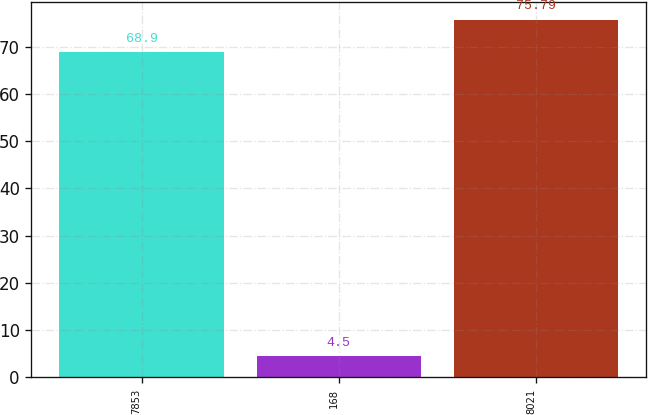Convert chart. <chart><loc_0><loc_0><loc_500><loc_500><bar_chart><fcel>7853<fcel>168<fcel>8021<nl><fcel>68.9<fcel>4.5<fcel>75.79<nl></chart> 